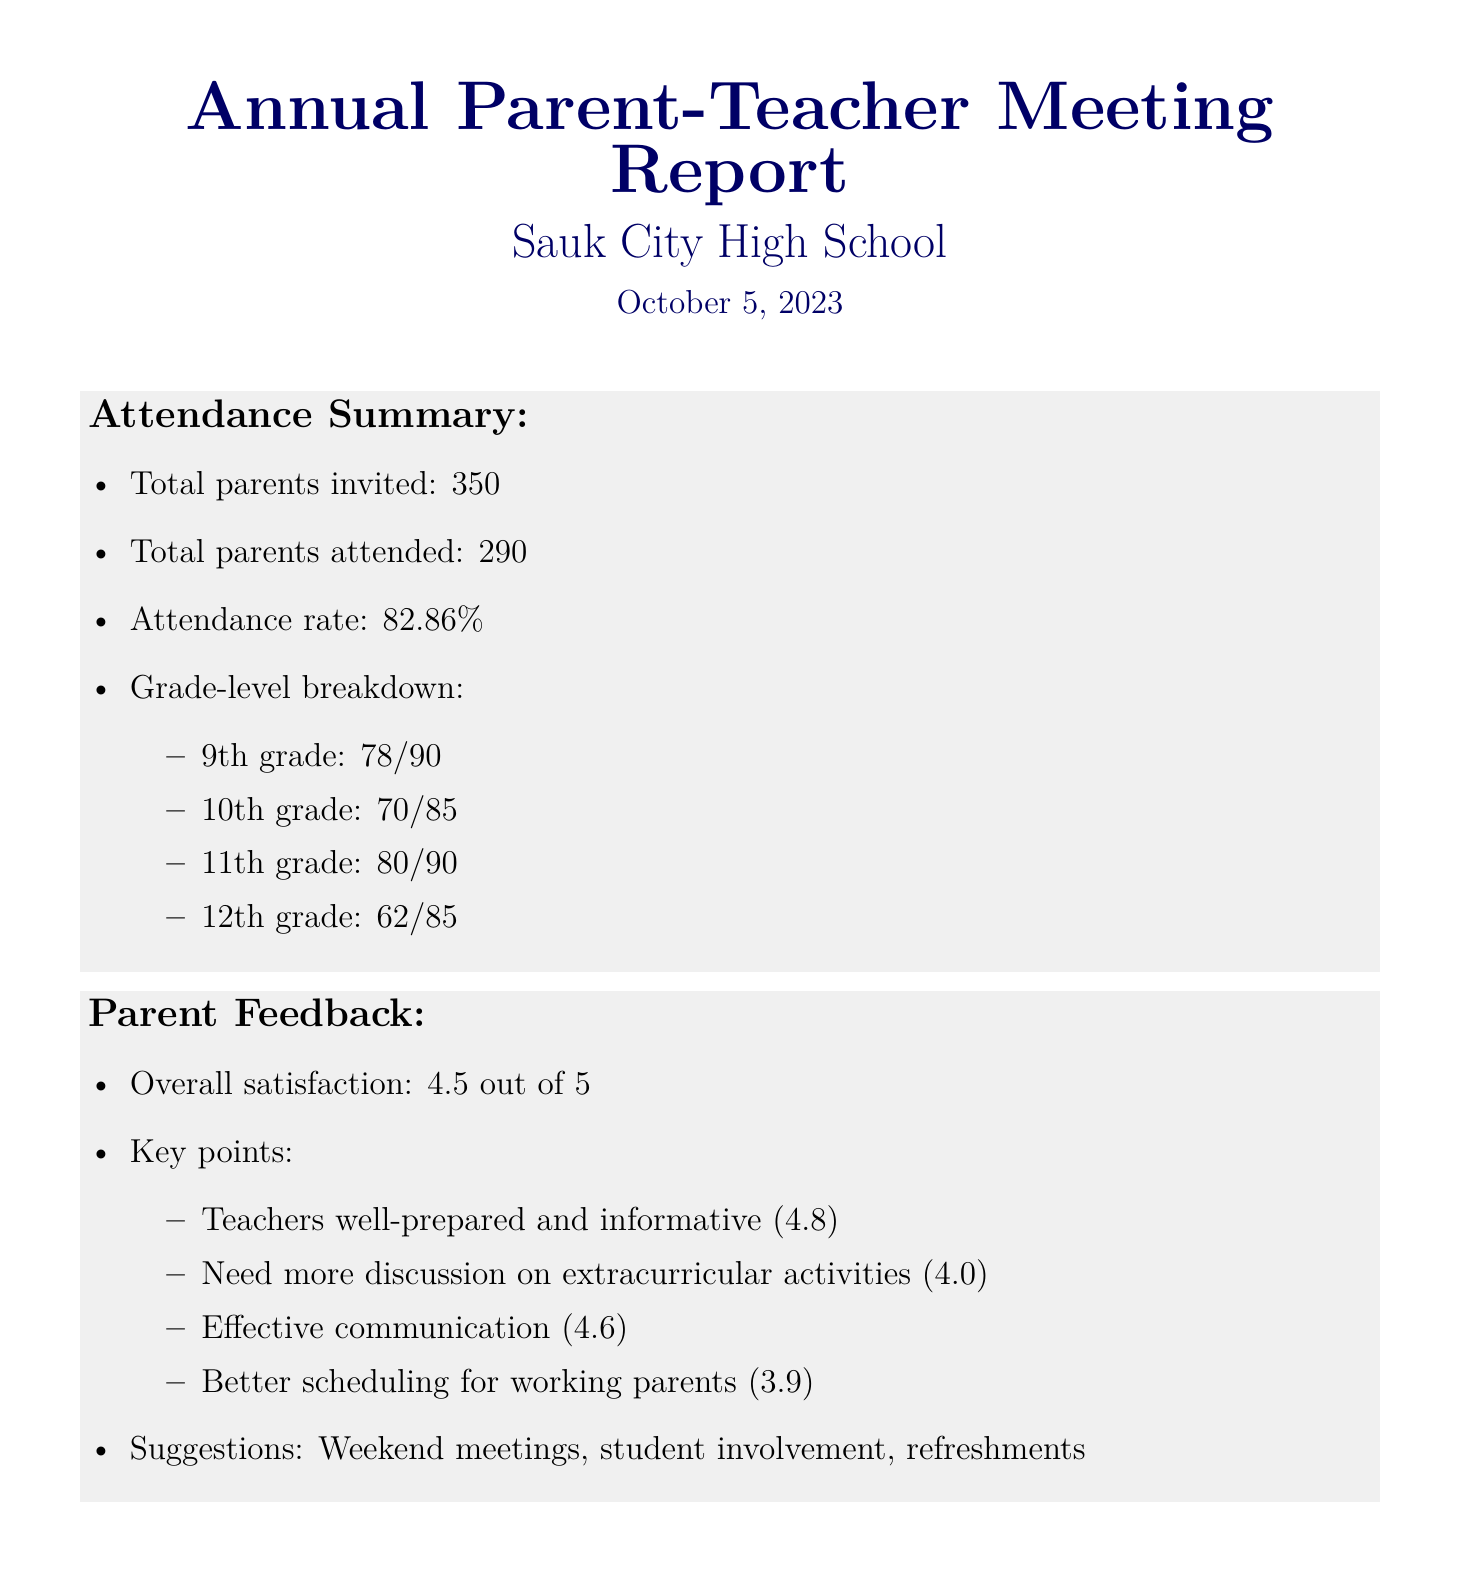What is the total number of parents invited? The total number of parents invited is provided in the attendance summary section of the document.
Answer: 350 What is the attendance rate? The attendance rate is calculated based on the total parents invited and the total parents attended, which is listed in the document.
Answer: 82.86% How many parents attended from the 11th grade? The document specifies the number of parents who attended from each grade level as part of the attendance breakdown.
Answer: 80 What was the overall satisfaction rating? The overall satisfaction rating is stated in the parent feedback section, summarizing the feedback received.
Answer: 4.5 out of 5 What suggestion was made for improving meetings? The feedback includes specific suggestions for making parent-teacher meetings more effective, listed in the document.
Answer: Weekend meetings What is one of the action plans regarding student involvement? The action plans section outlines the initiatives to promote student participation during meetings.
Answer: Students to present achievements and challenges When is the implementation timeline for the action plans? The timeline for implementing the proposed action plans is explicitly provided in the document.
Answer: November 2023 - March 2024 What was the rating for effective communication? The feedback section includes specific ratings for various aspects of the parent-teacher meetings.
Answer: 4.6 What was one key point regarding extracurricular activities? The feedback section addresses parents' desires for more information on specific topics, including extracurricular activities.
Answer: Need more discussion on extracurricular activities 